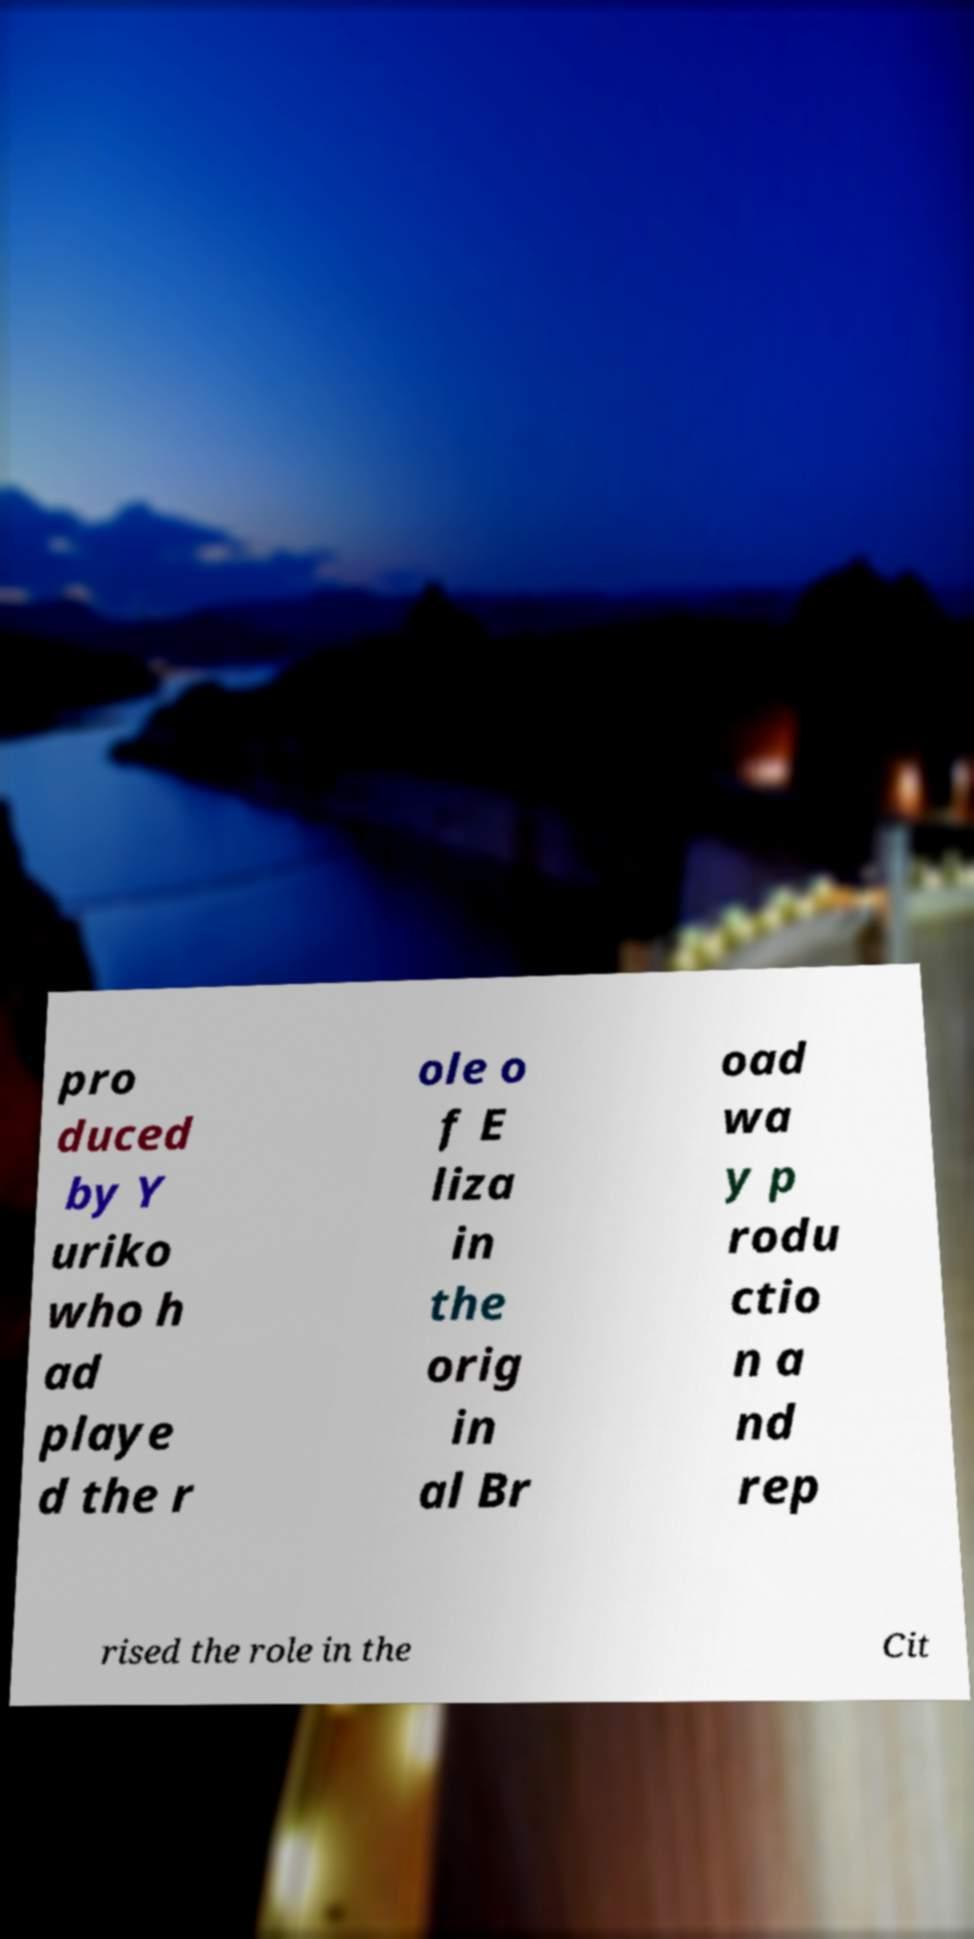Could you assist in decoding the text presented in this image and type it out clearly? pro duced by Y uriko who h ad playe d the r ole o f E liza in the orig in al Br oad wa y p rodu ctio n a nd rep rised the role in the Cit 